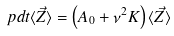<formula> <loc_0><loc_0><loc_500><loc_500>\ p d { t } { \langle \vec { Z } \rangle } = \left ( A _ { 0 } + \nu ^ { 2 } K \right ) \langle \vec { Z } \rangle</formula> 